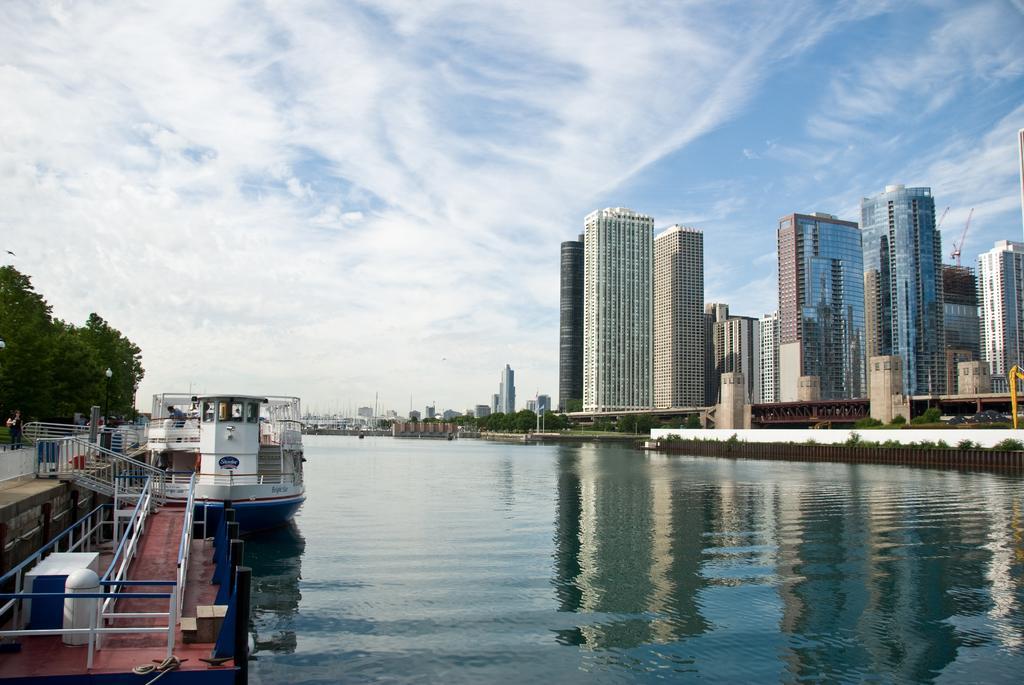In one or two sentences, can you explain what this image depicts? At the bottom of the picture, we see water and this water might be in the canal. On the left side, we see a boat, staircase and a railing. Behind that, we see trees. On the right side, there are buildings. In the background, there are trees and buildings. At the top of the picture, we see the sky. 